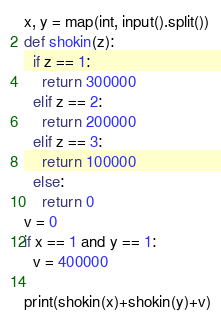<code> <loc_0><loc_0><loc_500><loc_500><_Python_>x, y = map(int, input().split())
def shokin(z):
  if z == 1:
    return 300000
  elif z == 2:
    return 200000
  elif z == 3:
    return 100000
  else:
    return 0
v = 0
if x == 1 and y == 1:
  v = 400000
  
print(shokin(x)+shokin(y)+v)</code> 